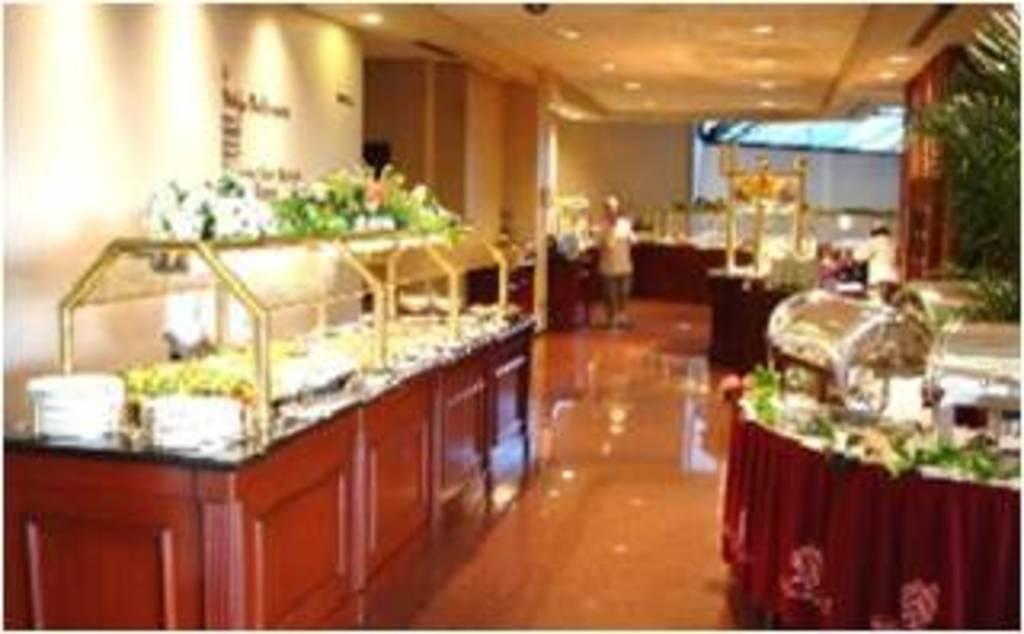Please provide a concise description of this image. In this image we can see inside of the house. There are many tables in the image. There is a person in the image. There is a house plant in the image. There are many lamps attached to the roof. 